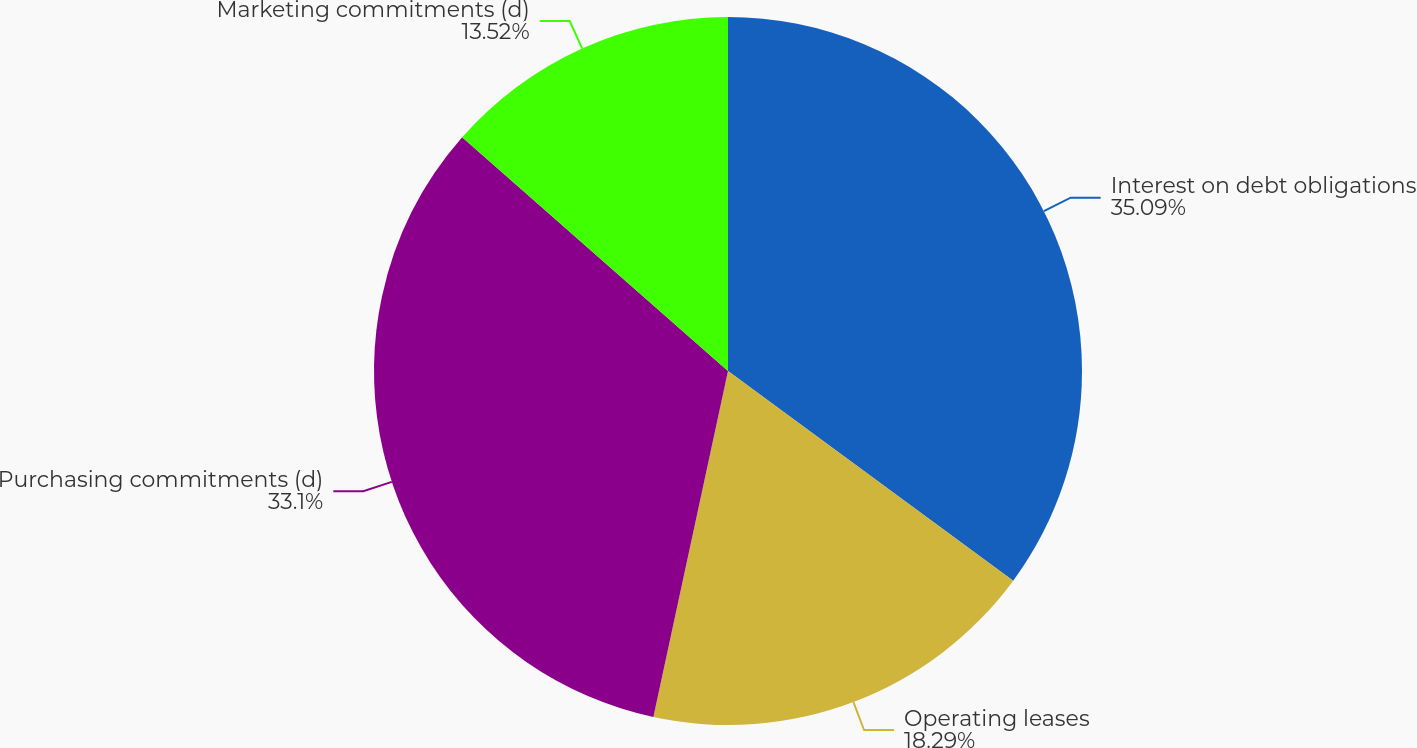Convert chart. <chart><loc_0><loc_0><loc_500><loc_500><pie_chart><fcel>Interest on debt obligations<fcel>Operating leases<fcel>Purchasing commitments (d)<fcel>Marketing commitments (d)<nl><fcel>35.09%<fcel>18.29%<fcel>33.1%<fcel>13.52%<nl></chart> 